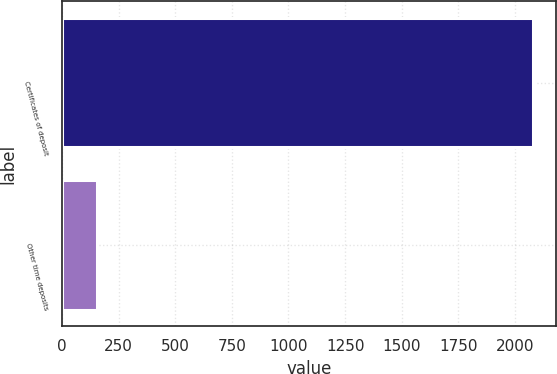Convert chart to OTSL. <chart><loc_0><loc_0><loc_500><loc_500><bar_chart><fcel>Certificates of deposit<fcel>Other time deposits<nl><fcel>2078<fcel>157<nl></chart> 